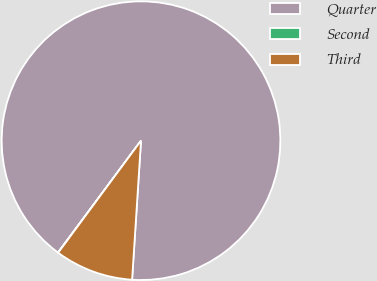Convert chart. <chart><loc_0><loc_0><loc_500><loc_500><pie_chart><fcel>Quarter<fcel>Second<fcel>Third<nl><fcel>90.86%<fcel>0.03%<fcel>9.11%<nl></chart> 